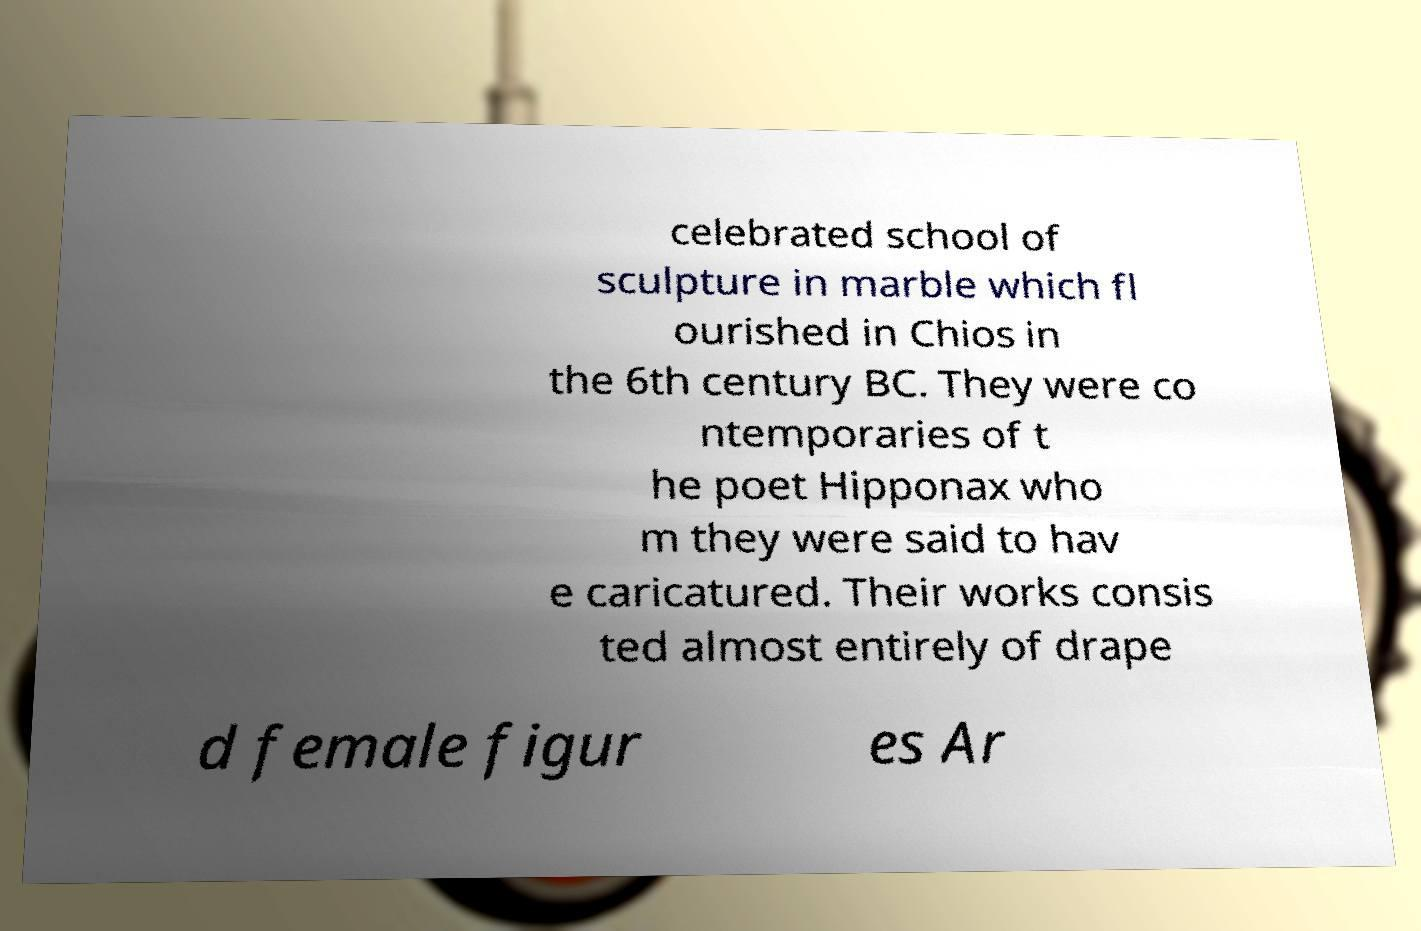What messages or text are displayed in this image? I need them in a readable, typed format. celebrated school of sculpture in marble which fl ourished in Chios in the 6th century BC. They were co ntemporaries of t he poet Hipponax who m they were said to hav e caricatured. Their works consis ted almost entirely of drape d female figur es Ar 